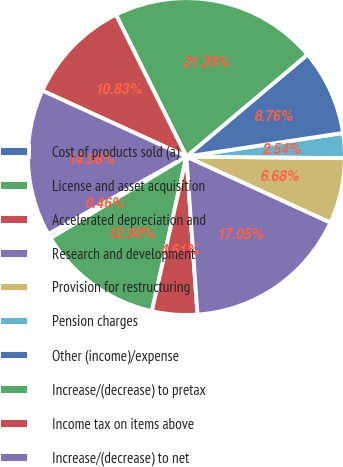<chart> <loc_0><loc_0><loc_500><loc_500><pie_chart><fcel>Cost of products sold (a)<fcel>License and asset acquisition<fcel>Accelerated depreciation and<fcel>Research and development<fcel>Provision for restructuring<fcel>Pension charges<fcel>Other (income)/expense<fcel>Increase/(decrease) to pretax<fcel>Income tax on items above<fcel>Increase/(decrease) to net<nl><fcel>0.46%<fcel>12.9%<fcel>4.61%<fcel>17.05%<fcel>6.68%<fcel>2.54%<fcel>8.76%<fcel>21.2%<fcel>10.83%<fcel>14.98%<nl></chart> 